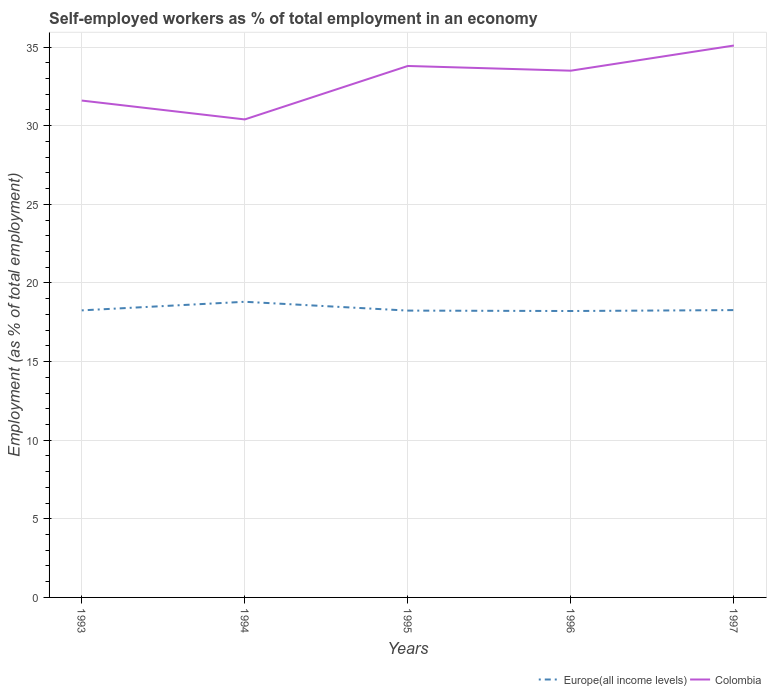How many different coloured lines are there?
Offer a terse response. 2. Is the number of lines equal to the number of legend labels?
Offer a very short reply. Yes. Across all years, what is the maximum percentage of self-employed workers in Europe(all income levels)?
Provide a succinct answer. 18.22. What is the total percentage of self-employed workers in Europe(all income levels) in the graph?
Make the answer very short. 0.03. What is the difference between the highest and the second highest percentage of self-employed workers in Colombia?
Make the answer very short. 4.7. What is the difference between the highest and the lowest percentage of self-employed workers in Europe(all income levels)?
Keep it short and to the point. 1. Is the percentage of self-employed workers in Europe(all income levels) strictly greater than the percentage of self-employed workers in Colombia over the years?
Ensure brevity in your answer.  Yes. How many lines are there?
Offer a terse response. 2. How many years are there in the graph?
Provide a short and direct response. 5. What is the difference between two consecutive major ticks on the Y-axis?
Offer a terse response. 5. Are the values on the major ticks of Y-axis written in scientific E-notation?
Provide a succinct answer. No. Does the graph contain any zero values?
Provide a short and direct response. No. How are the legend labels stacked?
Provide a succinct answer. Horizontal. What is the title of the graph?
Provide a short and direct response. Self-employed workers as % of total employment in an economy. Does "Brunei Darussalam" appear as one of the legend labels in the graph?
Offer a terse response. No. What is the label or title of the Y-axis?
Your answer should be compact. Employment (as % of total employment). What is the Employment (as % of total employment) in Europe(all income levels) in 1993?
Offer a very short reply. 18.26. What is the Employment (as % of total employment) of Colombia in 1993?
Give a very brief answer. 31.6. What is the Employment (as % of total employment) of Europe(all income levels) in 1994?
Keep it short and to the point. 18.8. What is the Employment (as % of total employment) of Colombia in 1994?
Your response must be concise. 30.4. What is the Employment (as % of total employment) in Europe(all income levels) in 1995?
Keep it short and to the point. 18.24. What is the Employment (as % of total employment) of Colombia in 1995?
Your answer should be compact. 33.8. What is the Employment (as % of total employment) in Europe(all income levels) in 1996?
Offer a very short reply. 18.22. What is the Employment (as % of total employment) in Colombia in 1996?
Make the answer very short. 33.5. What is the Employment (as % of total employment) in Europe(all income levels) in 1997?
Ensure brevity in your answer.  18.27. What is the Employment (as % of total employment) of Colombia in 1997?
Provide a short and direct response. 35.1. Across all years, what is the maximum Employment (as % of total employment) in Europe(all income levels)?
Make the answer very short. 18.8. Across all years, what is the maximum Employment (as % of total employment) of Colombia?
Your answer should be very brief. 35.1. Across all years, what is the minimum Employment (as % of total employment) of Europe(all income levels)?
Offer a very short reply. 18.22. Across all years, what is the minimum Employment (as % of total employment) of Colombia?
Ensure brevity in your answer.  30.4. What is the total Employment (as % of total employment) in Europe(all income levels) in the graph?
Your answer should be very brief. 91.79. What is the total Employment (as % of total employment) of Colombia in the graph?
Ensure brevity in your answer.  164.4. What is the difference between the Employment (as % of total employment) in Europe(all income levels) in 1993 and that in 1994?
Give a very brief answer. -0.55. What is the difference between the Employment (as % of total employment) in Europe(all income levels) in 1993 and that in 1995?
Ensure brevity in your answer.  0.01. What is the difference between the Employment (as % of total employment) in Europe(all income levels) in 1993 and that in 1996?
Offer a terse response. 0.04. What is the difference between the Employment (as % of total employment) of Europe(all income levels) in 1993 and that in 1997?
Give a very brief answer. -0.02. What is the difference between the Employment (as % of total employment) of Colombia in 1993 and that in 1997?
Ensure brevity in your answer.  -3.5. What is the difference between the Employment (as % of total employment) of Europe(all income levels) in 1994 and that in 1995?
Your answer should be compact. 0.56. What is the difference between the Employment (as % of total employment) in Colombia in 1994 and that in 1995?
Provide a short and direct response. -3.4. What is the difference between the Employment (as % of total employment) in Europe(all income levels) in 1994 and that in 1996?
Give a very brief answer. 0.59. What is the difference between the Employment (as % of total employment) in Colombia in 1994 and that in 1996?
Provide a succinct answer. -3.1. What is the difference between the Employment (as % of total employment) of Europe(all income levels) in 1994 and that in 1997?
Keep it short and to the point. 0.53. What is the difference between the Employment (as % of total employment) in Europe(all income levels) in 1995 and that in 1996?
Your answer should be compact. 0.03. What is the difference between the Employment (as % of total employment) in Colombia in 1995 and that in 1996?
Provide a short and direct response. 0.3. What is the difference between the Employment (as % of total employment) of Europe(all income levels) in 1995 and that in 1997?
Offer a terse response. -0.03. What is the difference between the Employment (as % of total employment) in Colombia in 1995 and that in 1997?
Make the answer very short. -1.3. What is the difference between the Employment (as % of total employment) of Europe(all income levels) in 1996 and that in 1997?
Your response must be concise. -0.06. What is the difference between the Employment (as % of total employment) in Colombia in 1996 and that in 1997?
Your response must be concise. -1.6. What is the difference between the Employment (as % of total employment) in Europe(all income levels) in 1993 and the Employment (as % of total employment) in Colombia in 1994?
Your response must be concise. -12.14. What is the difference between the Employment (as % of total employment) in Europe(all income levels) in 1993 and the Employment (as % of total employment) in Colombia in 1995?
Give a very brief answer. -15.54. What is the difference between the Employment (as % of total employment) of Europe(all income levels) in 1993 and the Employment (as % of total employment) of Colombia in 1996?
Provide a succinct answer. -15.24. What is the difference between the Employment (as % of total employment) of Europe(all income levels) in 1993 and the Employment (as % of total employment) of Colombia in 1997?
Ensure brevity in your answer.  -16.84. What is the difference between the Employment (as % of total employment) in Europe(all income levels) in 1994 and the Employment (as % of total employment) in Colombia in 1995?
Keep it short and to the point. -15. What is the difference between the Employment (as % of total employment) in Europe(all income levels) in 1994 and the Employment (as % of total employment) in Colombia in 1996?
Give a very brief answer. -14.7. What is the difference between the Employment (as % of total employment) of Europe(all income levels) in 1994 and the Employment (as % of total employment) of Colombia in 1997?
Make the answer very short. -16.3. What is the difference between the Employment (as % of total employment) of Europe(all income levels) in 1995 and the Employment (as % of total employment) of Colombia in 1996?
Ensure brevity in your answer.  -15.26. What is the difference between the Employment (as % of total employment) of Europe(all income levels) in 1995 and the Employment (as % of total employment) of Colombia in 1997?
Your answer should be very brief. -16.86. What is the difference between the Employment (as % of total employment) of Europe(all income levels) in 1996 and the Employment (as % of total employment) of Colombia in 1997?
Your response must be concise. -16.88. What is the average Employment (as % of total employment) in Europe(all income levels) per year?
Your answer should be compact. 18.36. What is the average Employment (as % of total employment) of Colombia per year?
Your answer should be very brief. 32.88. In the year 1993, what is the difference between the Employment (as % of total employment) of Europe(all income levels) and Employment (as % of total employment) of Colombia?
Your answer should be very brief. -13.34. In the year 1994, what is the difference between the Employment (as % of total employment) in Europe(all income levels) and Employment (as % of total employment) in Colombia?
Give a very brief answer. -11.6. In the year 1995, what is the difference between the Employment (as % of total employment) of Europe(all income levels) and Employment (as % of total employment) of Colombia?
Provide a short and direct response. -15.56. In the year 1996, what is the difference between the Employment (as % of total employment) in Europe(all income levels) and Employment (as % of total employment) in Colombia?
Provide a short and direct response. -15.28. In the year 1997, what is the difference between the Employment (as % of total employment) in Europe(all income levels) and Employment (as % of total employment) in Colombia?
Provide a short and direct response. -16.83. What is the ratio of the Employment (as % of total employment) of Europe(all income levels) in 1993 to that in 1994?
Your answer should be very brief. 0.97. What is the ratio of the Employment (as % of total employment) of Colombia in 1993 to that in 1994?
Offer a very short reply. 1.04. What is the ratio of the Employment (as % of total employment) in Colombia in 1993 to that in 1995?
Give a very brief answer. 0.93. What is the ratio of the Employment (as % of total employment) in Colombia in 1993 to that in 1996?
Offer a very short reply. 0.94. What is the ratio of the Employment (as % of total employment) of Europe(all income levels) in 1993 to that in 1997?
Provide a succinct answer. 1. What is the ratio of the Employment (as % of total employment) of Colombia in 1993 to that in 1997?
Give a very brief answer. 0.9. What is the ratio of the Employment (as % of total employment) of Europe(all income levels) in 1994 to that in 1995?
Keep it short and to the point. 1.03. What is the ratio of the Employment (as % of total employment) of Colombia in 1994 to that in 1995?
Your response must be concise. 0.9. What is the ratio of the Employment (as % of total employment) of Europe(all income levels) in 1994 to that in 1996?
Give a very brief answer. 1.03. What is the ratio of the Employment (as % of total employment) of Colombia in 1994 to that in 1996?
Ensure brevity in your answer.  0.91. What is the ratio of the Employment (as % of total employment) in Europe(all income levels) in 1994 to that in 1997?
Your answer should be compact. 1.03. What is the ratio of the Employment (as % of total employment) of Colombia in 1994 to that in 1997?
Give a very brief answer. 0.87. What is the ratio of the Employment (as % of total employment) in Europe(all income levels) in 1995 to that in 1996?
Provide a short and direct response. 1. What is the ratio of the Employment (as % of total employment) of Colombia in 1996 to that in 1997?
Offer a very short reply. 0.95. What is the difference between the highest and the second highest Employment (as % of total employment) of Europe(all income levels)?
Your response must be concise. 0.53. What is the difference between the highest and the second highest Employment (as % of total employment) of Colombia?
Your answer should be compact. 1.3. What is the difference between the highest and the lowest Employment (as % of total employment) of Europe(all income levels)?
Offer a terse response. 0.59. What is the difference between the highest and the lowest Employment (as % of total employment) of Colombia?
Provide a short and direct response. 4.7. 